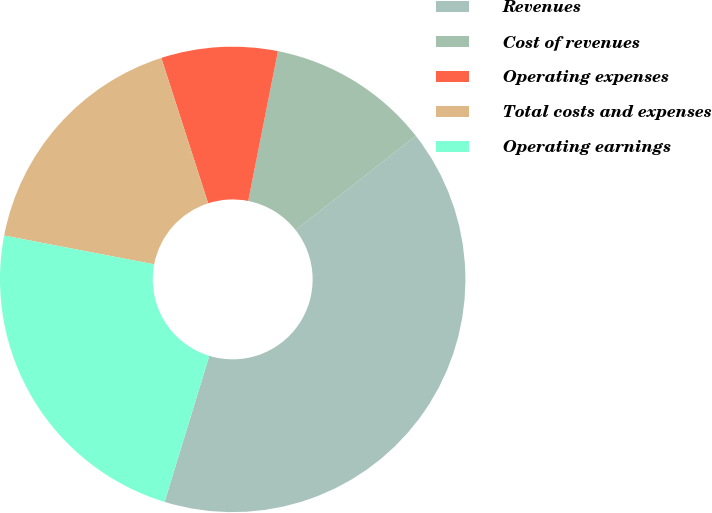Convert chart. <chart><loc_0><loc_0><loc_500><loc_500><pie_chart><fcel>Revenues<fcel>Cost of revenues<fcel>Operating expenses<fcel>Total costs and expenses<fcel>Operating earnings<nl><fcel>40.31%<fcel>11.3%<fcel>8.08%<fcel>17.02%<fcel>23.29%<nl></chart> 